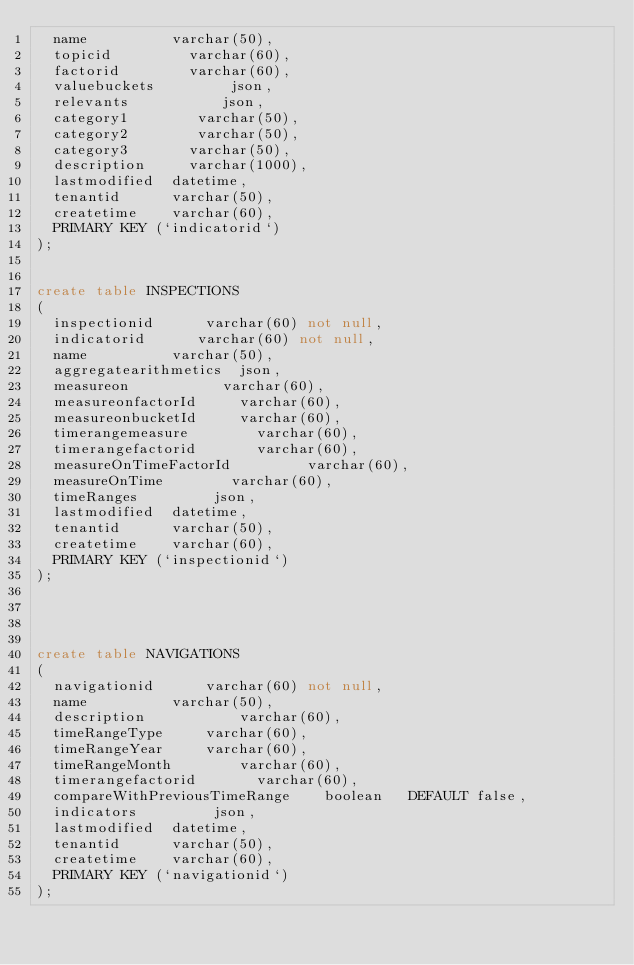<code> <loc_0><loc_0><loc_500><loc_500><_SQL_>  name          varchar(50),
  topicid         varchar(60),
  factorid        varchar(60),
  valuebuckets         json,
  relevants           json,
  category1        varchar(50),
  category2        varchar(50),
  category3       varchar(50),
  description     varchar(1000),
  lastmodified  datetime,
  tenantid      varchar(50),
  createtime    varchar(60),
  PRIMARY KEY (`indicatorid`)
);


create table INSPECTIONS 
(
  inspectionid      varchar(60) not null,
  indicatorid      varchar(60) not null,
  name          varchar(50),
  aggregatearithmetics  json,
  measureon           varchar(60),
  measureonfactorId     varchar(60),
  measureonbucketId     varchar(60),
  timerangemeasure        varchar(60),
  timerangefactorid       varchar(60),
  measureOnTimeFactorId         varchar(60),
  measureOnTime        varchar(60),
  timeRanges         json,
  lastmodified  datetime,
  tenantid      varchar(50),
  createtime    varchar(60),
  PRIMARY KEY (`inspectionid`)
);




create table NAVIGATIONS
(
  navigationid      varchar(60) not null,
  name          varchar(50),
  description           varchar(60),
  timeRangeType     varchar(60),
  timeRangeYear     varchar(60),
  timeRangeMonth        varchar(60),
  timerangefactorid       varchar(60),
  compareWithPreviousTimeRange    boolean   DEFAULT false,
  indicators         json,
  lastmodified  datetime,
  tenantid      varchar(50),
  createtime    varchar(60),
  PRIMARY KEY (`navigationid`)
);
</code> 